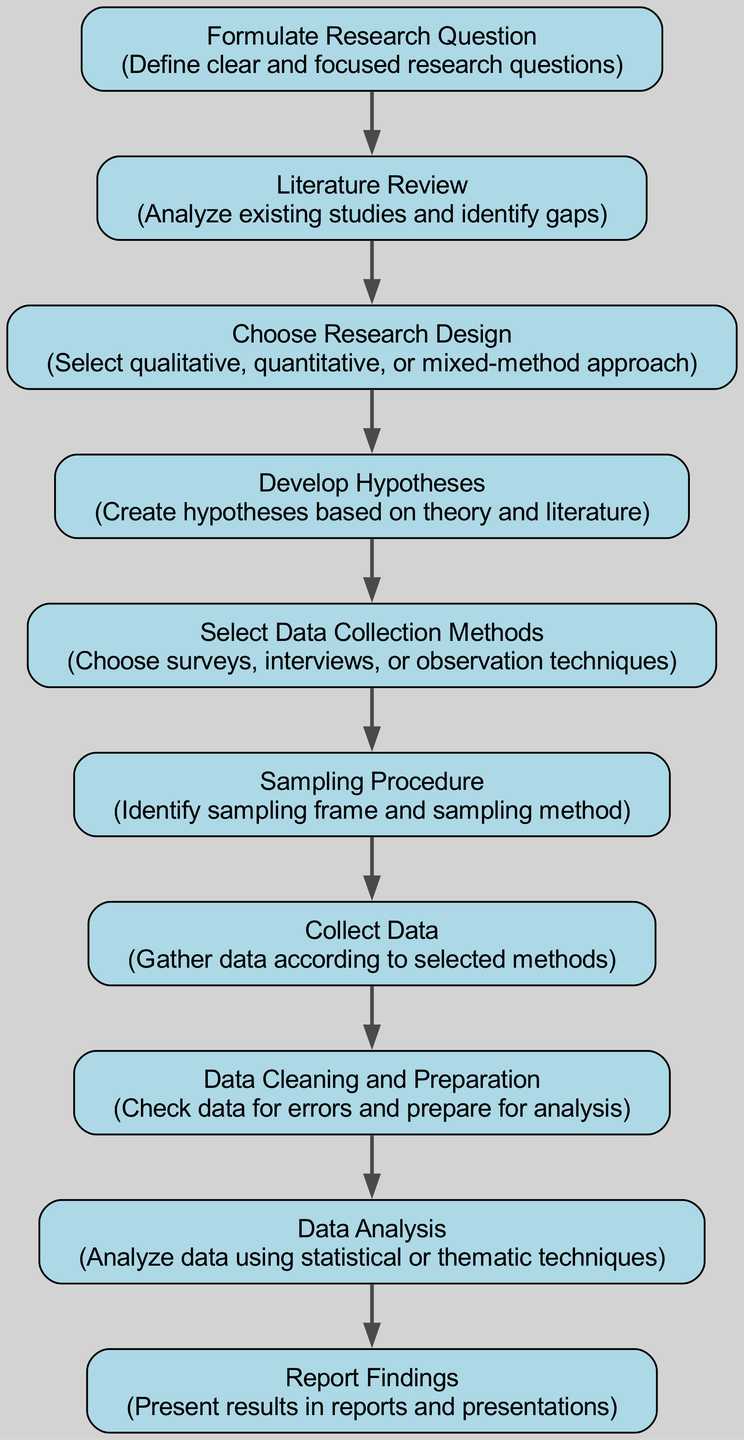What is the first step in the social research process? The first step is to "Formulate Research Question," which focuses on defining clear and focused research questions as the foundation for the research.
Answer: Formulate Research Question How many nodes are in the diagram? Counting all the distinct stages listed in the diagram, there are ten nodes representing different steps in the social research process.
Answer: Ten What follows after the "Literature Review"? The next step after "Literature Review" is "Choose Research Design," which indicates the transition from reviewing existing studies to selecting an appropriate methodology.
Answer: Choose Research Design What is the final stage before reporting findings? The last stage before reporting findings is "Data Analysis," where the collected data is analyzed using statistical or thematic techniques to derive insights.
Answer: Data Analysis Which step is directly after "Collect Data"? "Data Cleaning and Preparation" is the step that follows "Collect Data," indicating the need to process and ensure the data's accuracy before analysis.
Answer: Data Cleaning and Preparation What type of research design can be chosen? The research design that can be chosen can be qualitative, quantitative, or mixed-method approach, providing flexibility based on the nature of the research question.
Answer: Qualitative, quantitative, or mixed-method How many edges connect the nodes in the diagram? By counting the directed connections (edges) that link the stages in the social research process, there are nine edges illustrating the flow from one step to the next.
Answer: Nine What is the purpose of the "Develop Hypotheses" step? The purpose of "Develop Hypotheses" is to create hypotheses based on theoretical frameworks and insights gained from the literature, guiding the research focus.
Answer: Create hypotheses What must be done following the selection of data collection methods? After selecting data collection methods, the next step is to conduct the "Sampling Procedure," identifying the sampling frame and method to be used in the research.
Answer: Sampling Procedure What does the "Data Cleaning and Preparation" step ensure? The "Data Cleaning and Preparation" step ensures that the data is checked for errors and is formatted appropriately before it moves on to analysis, enhancing the quality of findings.
Answer: Check data for errors and prepare for analysis 